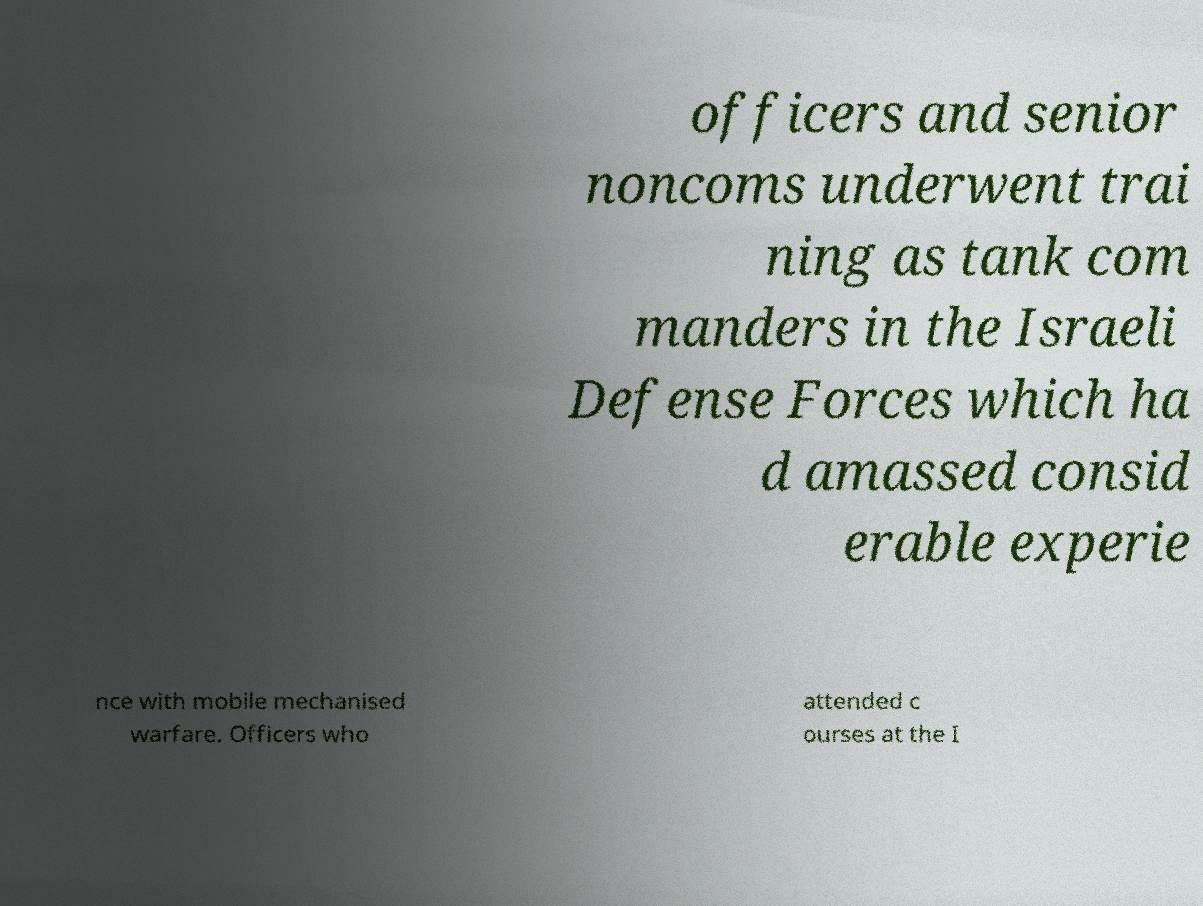Could you extract and type out the text from this image? officers and senior noncoms underwent trai ning as tank com manders in the Israeli Defense Forces which ha d amassed consid erable experie nce with mobile mechanised warfare. Officers who attended c ourses at the I 